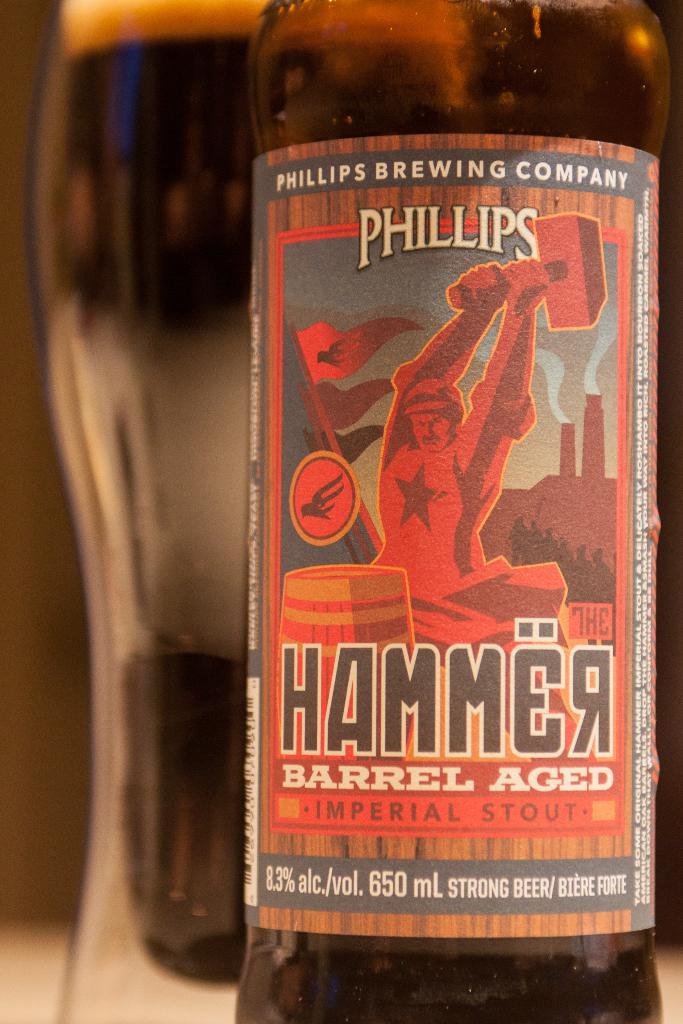What is the name of the brewery that made this beer?
Your answer should be very brief. Phillips brewing company. How did they age this drink?
Ensure brevity in your answer.  Barrel aged. 